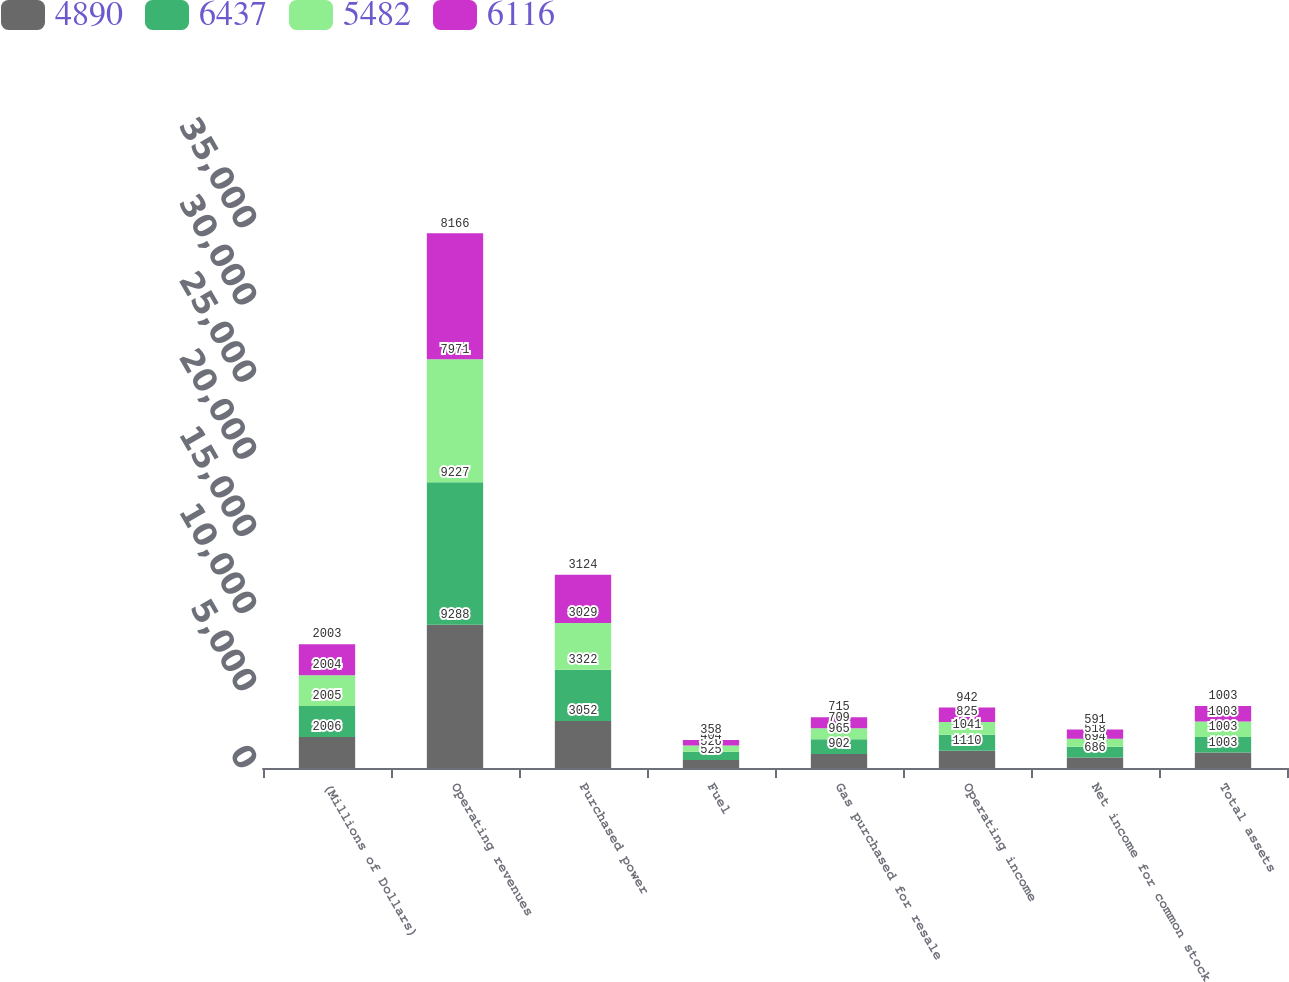Convert chart. <chart><loc_0><loc_0><loc_500><loc_500><stacked_bar_chart><ecel><fcel>(Millions of Dollars)<fcel>Operating revenues<fcel>Purchased power<fcel>Fuel<fcel>Gas purchased for resale<fcel>Operating income<fcel>Net income for common stock<fcel>Total assets<nl><fcel>4890<fcel>2006<fcel>9288<fcel>3052<fcel>525<fcel>902<fcel>1110<fcel>686<fcel>1003<nl><fcel>6437<fcel>2005<fcel>9227<fcel>3322<fcel>526<fcel>965<fcel>1041<fcel>694<fcel>1003<nl><fcel>5482<fcel>2004<fcel>7971<fcel>3029<fcel>404<fcel>709<fcel>825<fcel>518<fcel>1003<nl><fcel>6116<fcel>2003<fcel>8166<fcel>3124<fcel>358<fcel>715<fcel>942<fcel>591<fcel>1003<nl></chart> 